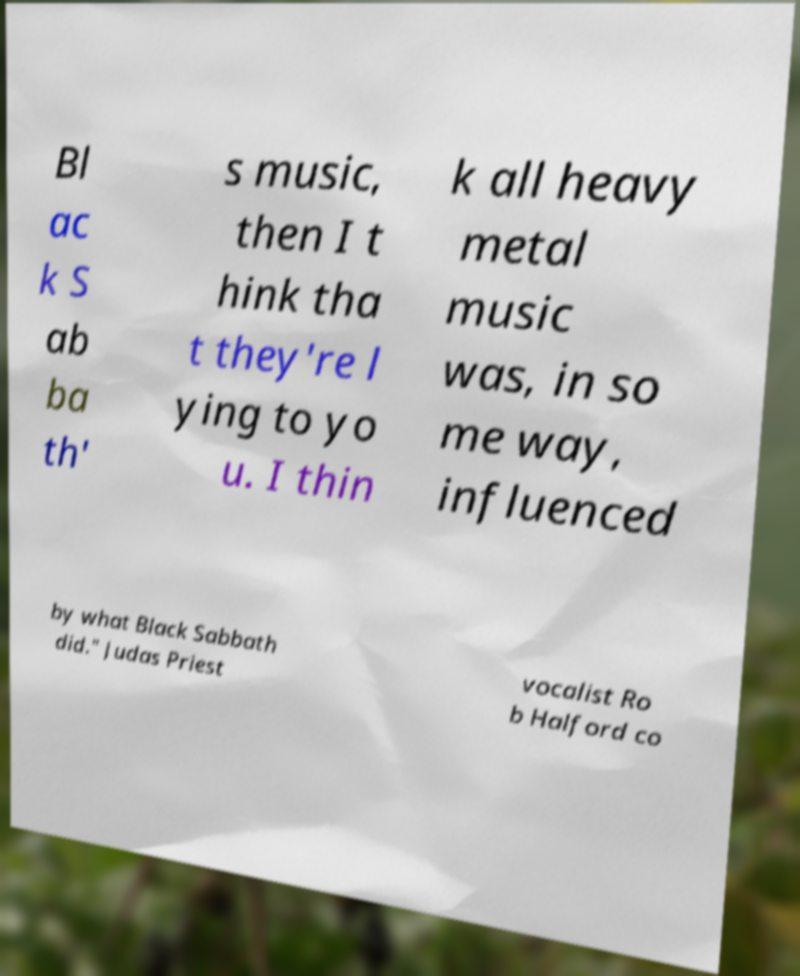I need the written content from this picture converted into text. Can you do that? Bl ac k S ab ba th' s music, then I t hink tha t they're l ying to yo u. I thin k all heavy metal music was, in so me way, influenced by what Black Sabbath did." Judas Priest vocalist Ro b Halford co 